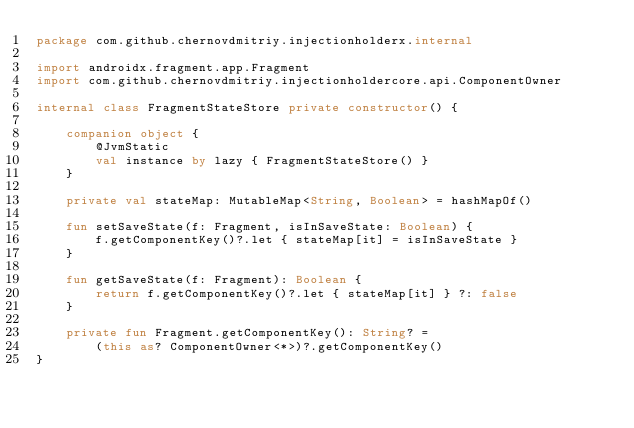Convert code to text. <code><loc_0><loc_0><loc_500><loc_500><_Kotlin_>package com.github.chernovdmitriy.injectionholderx.internal

import androidx.fragment.app.Fragment
import com.github.chernovdmitriy.injectionholdercore.api.ComponentOwner

internal class FragmentStateStore private constructor() {

    companion object {
        @JvmStatic
        val instance by lazy { FragmentStateStore() }
    }

    private val stateMap: MutableMap<String, Boolean> = hashMapOf()

    fun setSaveState(f: Fragment, isInSaveState: Boolean) {
        f.getComponentKey()?.let { stateMap[it] = isInSaveState }
    }

    fun getSaveState(f: Fragment): Boolean {
        return f.getComponentKey()?.let { stateMap[it] } ?: false
    }

    private fun Fragment.getComponentKey(): String? =
        (this as? ComponentOwner<*>)?.getComponentKey()
}</code> 